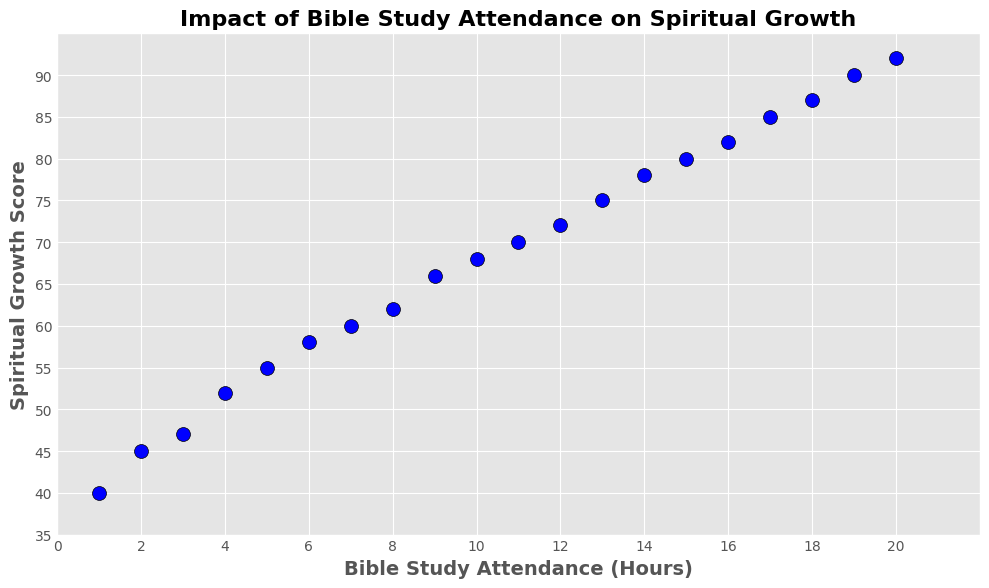What is the Spiritual Growth Score for 10 hours of Bible Study Attendance? Looking at the plot, find the data point at the intersection of 10 hours on the x-axis and trace upwards to see the corresponding y-axis value. The Spiritual Growth Score is the y-axis value at that point.
Answer: 68 Does the Spiritual Growth Score increase as Bible Study Attendance Hours increase? Examine the overall trend of the data points from left to right. If there is an upward trajectory, it indicates that the Spiritual Growth Score increases as the attendance hours increase.
Answer: Yes Which interval of Bible Study Attendance Hours shows the largest increase in Spiritual Growth Score? Compare the increments in Spiritual Growth Scores between successive attendance hours and identify the interval with the largest increase. For instance, between 1 and 2 hours, the growth is from 40 to 45, i.e., an increase of 5, and so on.
Answer: 18 to 19 hours What is the average Spiritual Growth Score for Bible Study Attendance between 4 to 6 hours? Identify the Spiritual Growth Scores for 4, 5, and 6 hours from the plot. Add these scores (52, 55, 58) and divide by 3 to find the average.
Answer: 55 At how many hours of Bible Study Attendance does the Spiritual Growth Score reach 70? Locate the data point where the y-axis (Spiritual Growth Score) reaches 70 and trace it to the corresponding x-axis value (Attendance Hours).
Answer: 11 Compare the Spiritual Growth Scores for 5 hours and 15 hours of Bible Study Attendance. Which one is higher and by how much? Retrieve the Spiritual Growth Scores for 5 and 15 hours from the plot. Subtract the smaller score from the larger score.
Answer: 15 hours is higher by 25 Is there a data point that falls in the range of 85-90 on the Spiritual Growth Score axis? If so, at how many hours of attendance? Check the y-axis range between 85 and 90 and see if any data points lie within this range. Look at the x-axis value for that point.
Answer: Yes, at 17 hours and 19 hours What is the total Spiritual Growth Score for Bible Study Attendance from 3 to 4 hours? Find the Spiritual Growth Scores for 3 and 4 hours from the plot. Add these two scores (47 and 52).
Answer: 99 How many data points fall within the first half of the x-axis scale (0-10 hours)? Count the number of data points (attendance hours) between 0 and 10 from the plot.
Answer: 10 What visual feature distinguishes the representation of data points in the plot? Identify a visual trait common to all data points, such as color, shape, size, or edge detail.
Answer: Blue color, circular shape, black edge 